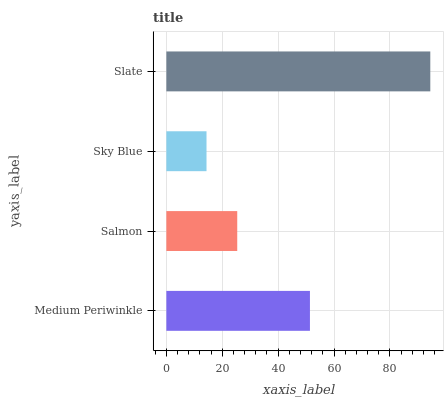Is Sky Blue the minimum?
Answer yes or no. Yes. Is Slate the maximum?
Answer yes or no. Yes. Is Salmon the minimum?
Answer yes or no. No. Is Salmon the maximum?
Answer yes or no. No. Is Medium Periwinkle greater than Salmon?
Answer yes or no. Yes. Is Salmon less than Medium Periwinkle?
Answer yes or no. Yes. Is Salmon greater than Medium Periwinkle?
Answer yes or no. No. Is Medium Periwinkle less than Salmon?
Answer yes or no. No. Is Medium Periwinkle the high median?
Answer yes or no. Yes. Is Salmon the low median?
Answer yes or no. Yes. Is Salmon the high median?
Answer yes or no. No. Is Slate the low median?
Answer yes or no. No. 